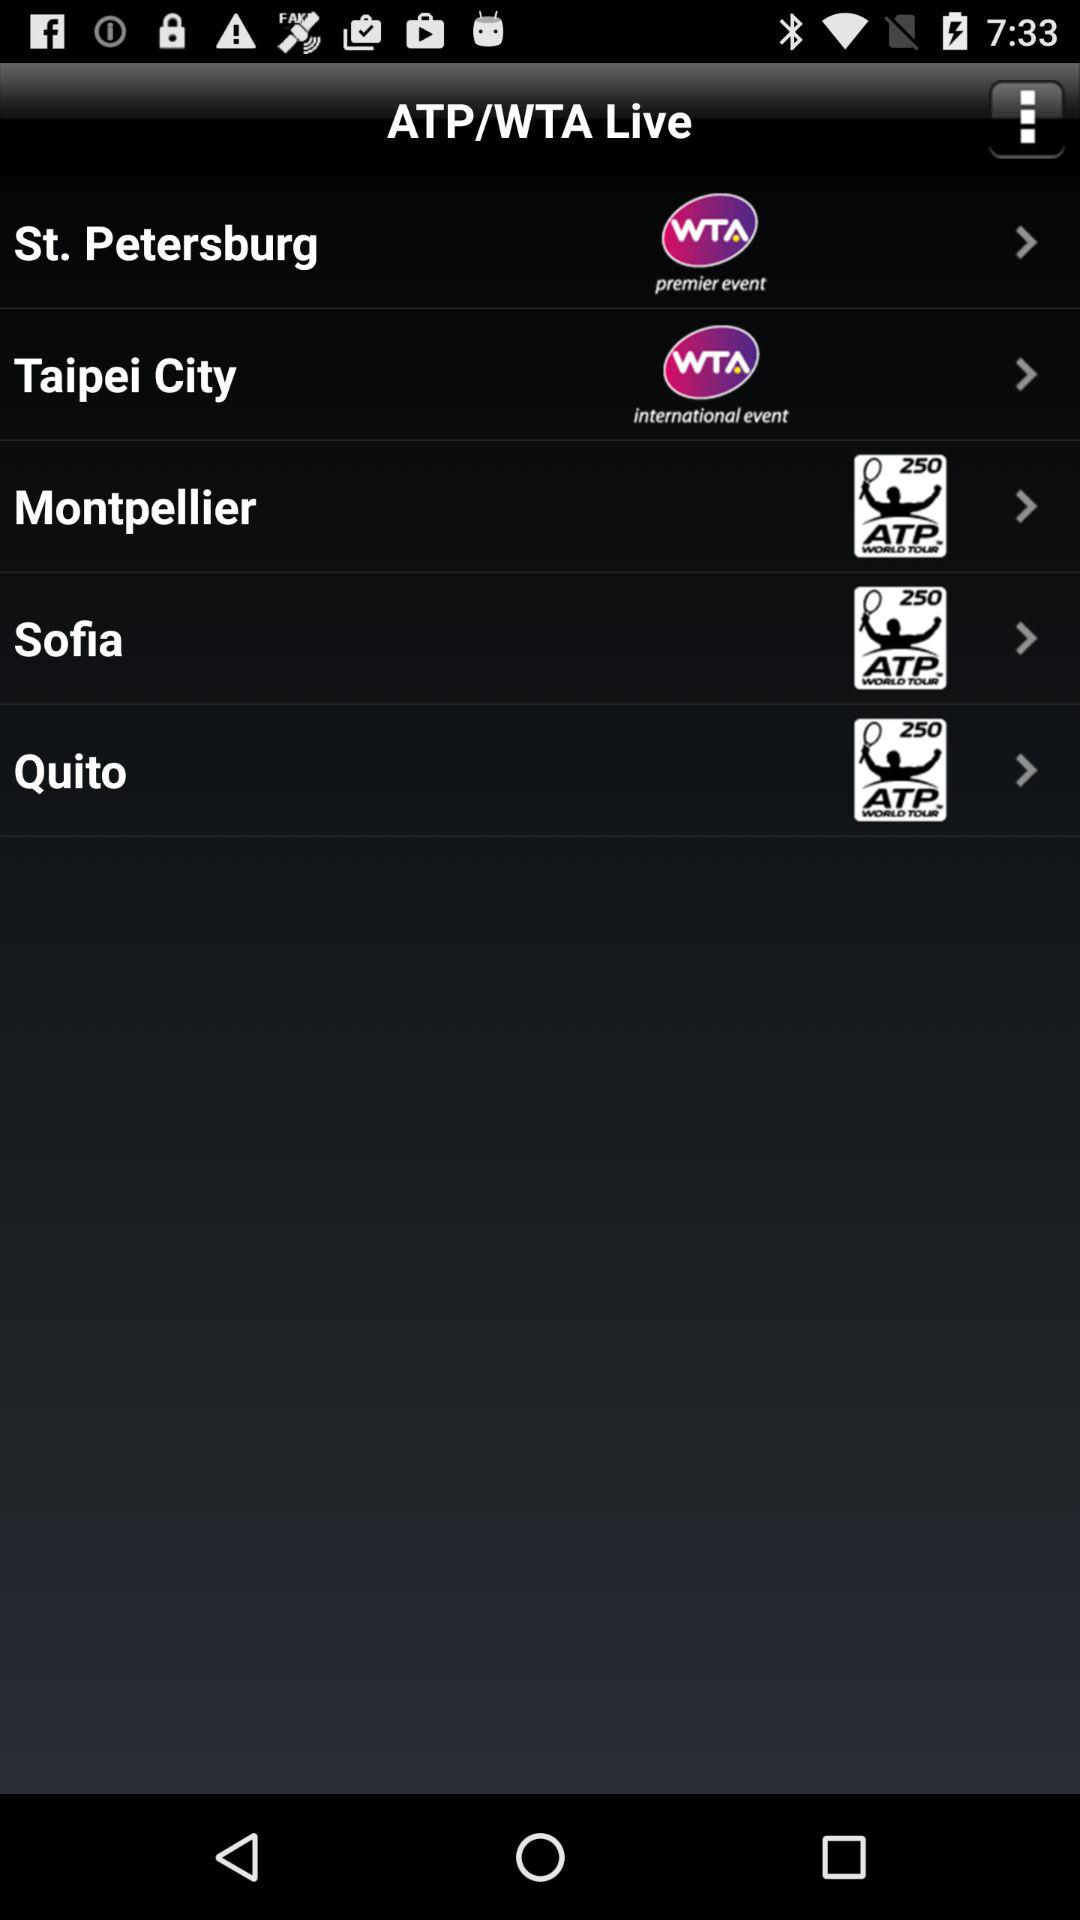How many events are currently live?
Answer the question using a single word or phrase. 5 